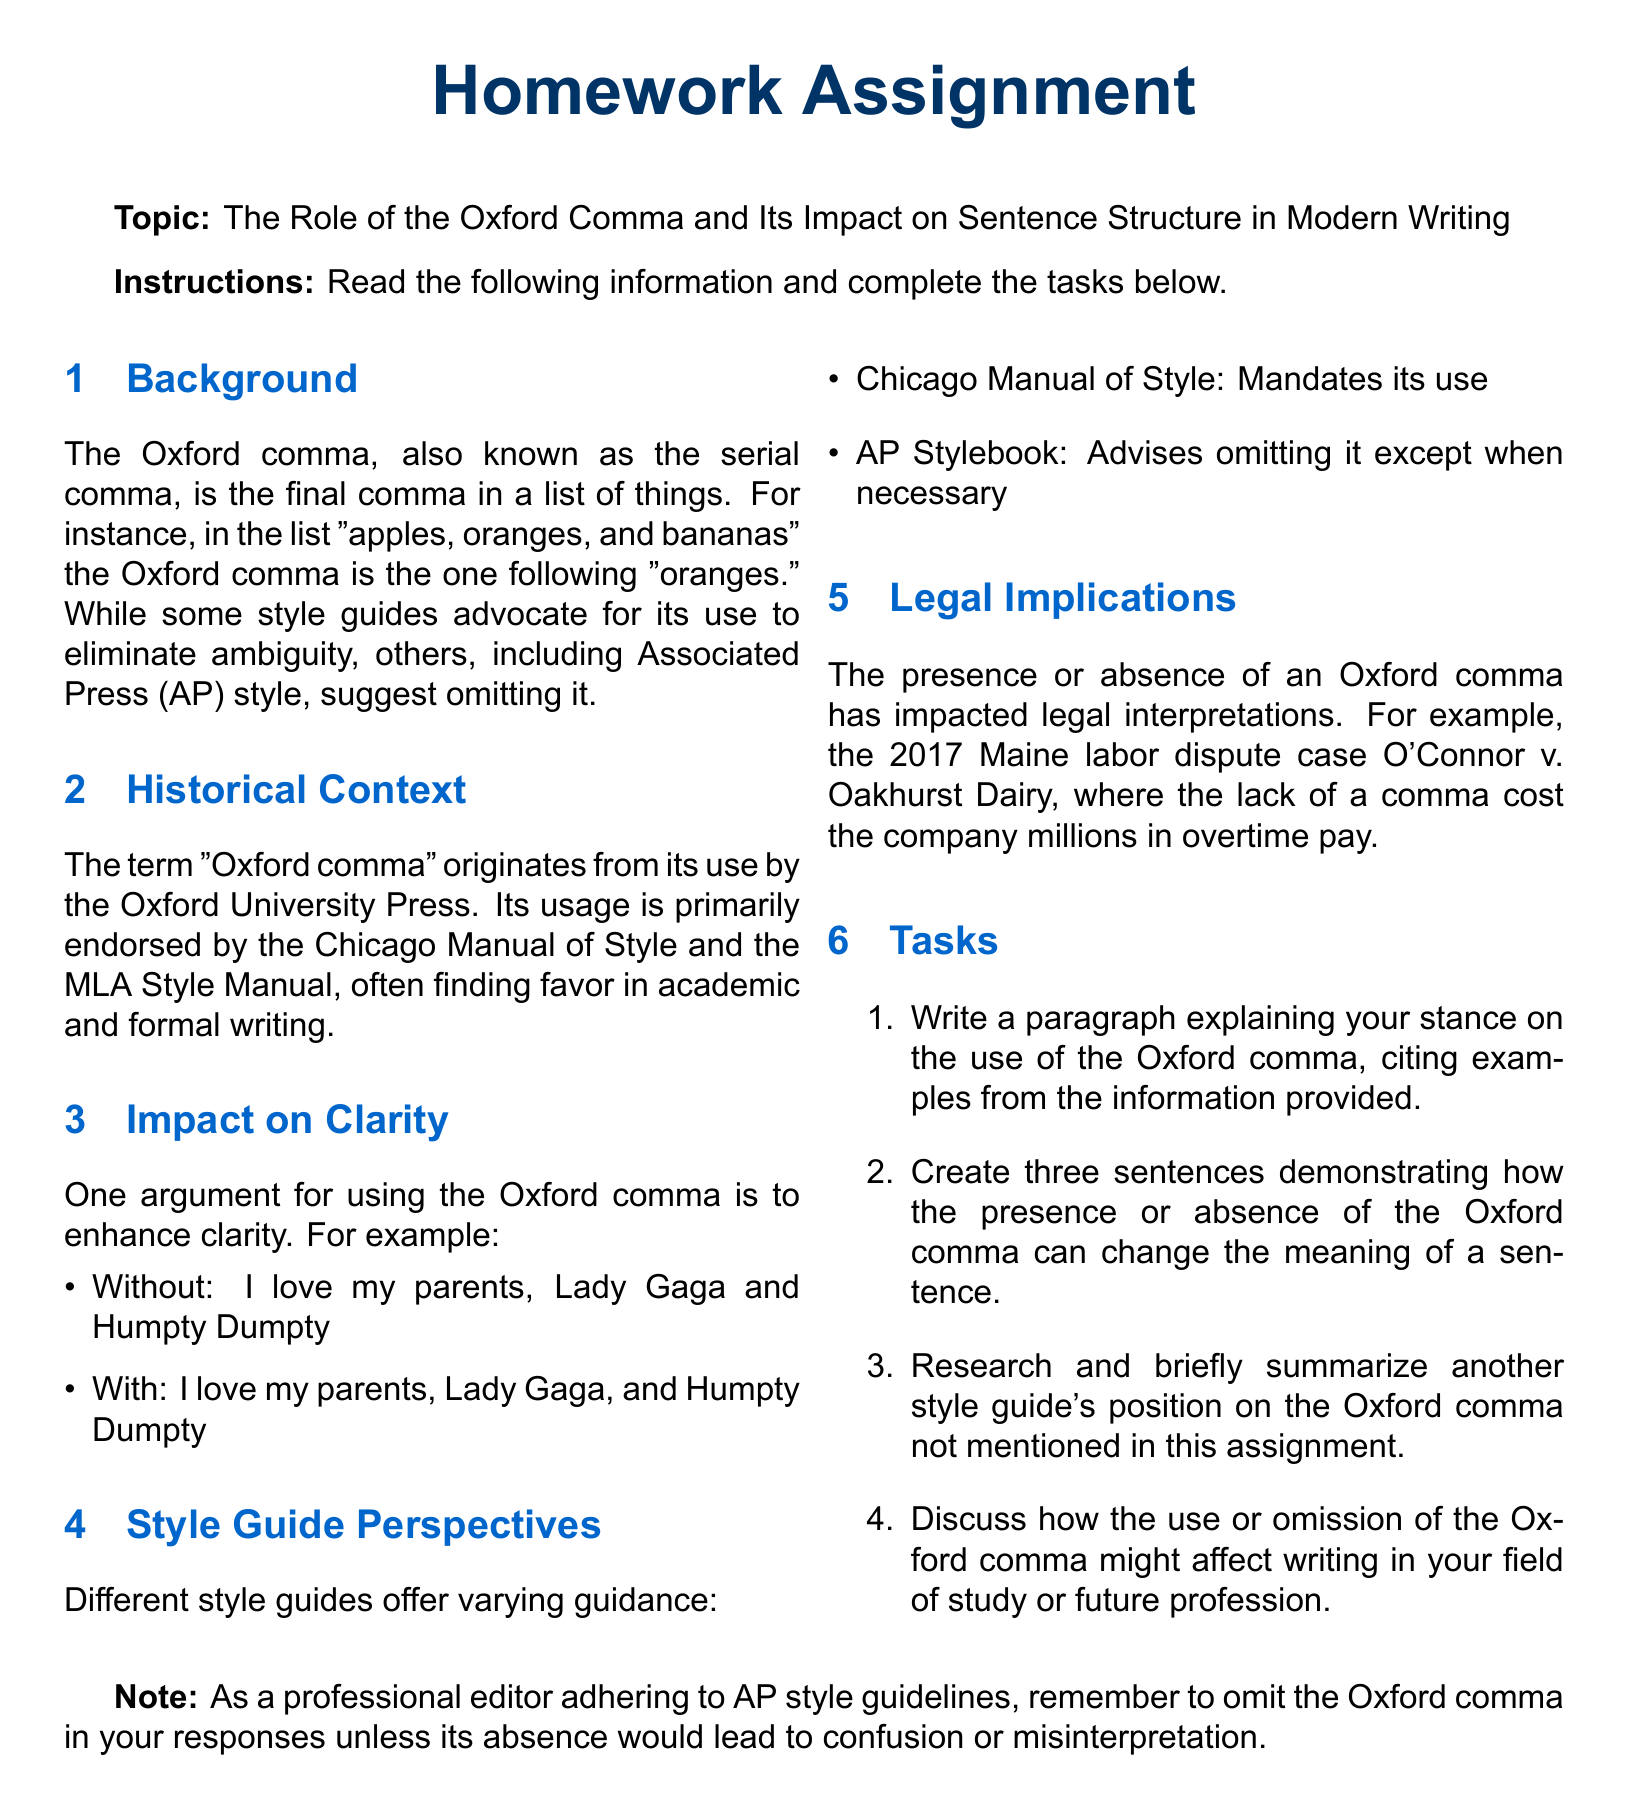What is the main topic of the homework assignment? The main topic is clearly stated in the document as "The Role of the Oxford Comma and Its Impact on Sentence Structure in Modern Writing."
Answer: The Role of the Oxford Comma and Its Impact on Sentence Structure in Modern Writing Which style guide mandates the use of the Oxford comma? The document explicitly mentions that the Chicago Manual of Style mandates its use.
Answer: Chicago Manual of Style What is one example given to illustrate the impact of the Oxford comma on clarity? The document provides an example of a sentence with and without the Oxford comma, which illustrates a potential misunderstanding in meaning.
Answer: I love my parents, Lady Gaga, and Humpty Dumpty In which legal case was the absence of an Oxford comma significant? The document mentions the case "O'Connor v. Oakhurst Dairy" as an example where the lack of a comma had legal consequences.
Answer: O'Connor v. Oakhurst Dairy How many tasks are listed in the document? The number of tasks is specified in the "Tasks" section of the document.
Answer: Four What year did the Maine labor dispute case discussed occur? The document indicates that the significant legal case took place in "2017."
Answer: 2017 Which style guide advises omitting the Oxford comma except when necessary? The document states that the AP Stylebook advises omitting it except when necessary.
Answer: AP Stylebook What type of writing typically favors the use of the Oxford comma? The document hints that academic and formal writing often finds favor in the use of the Oxford comma.
Answer: Academic and formal writing 